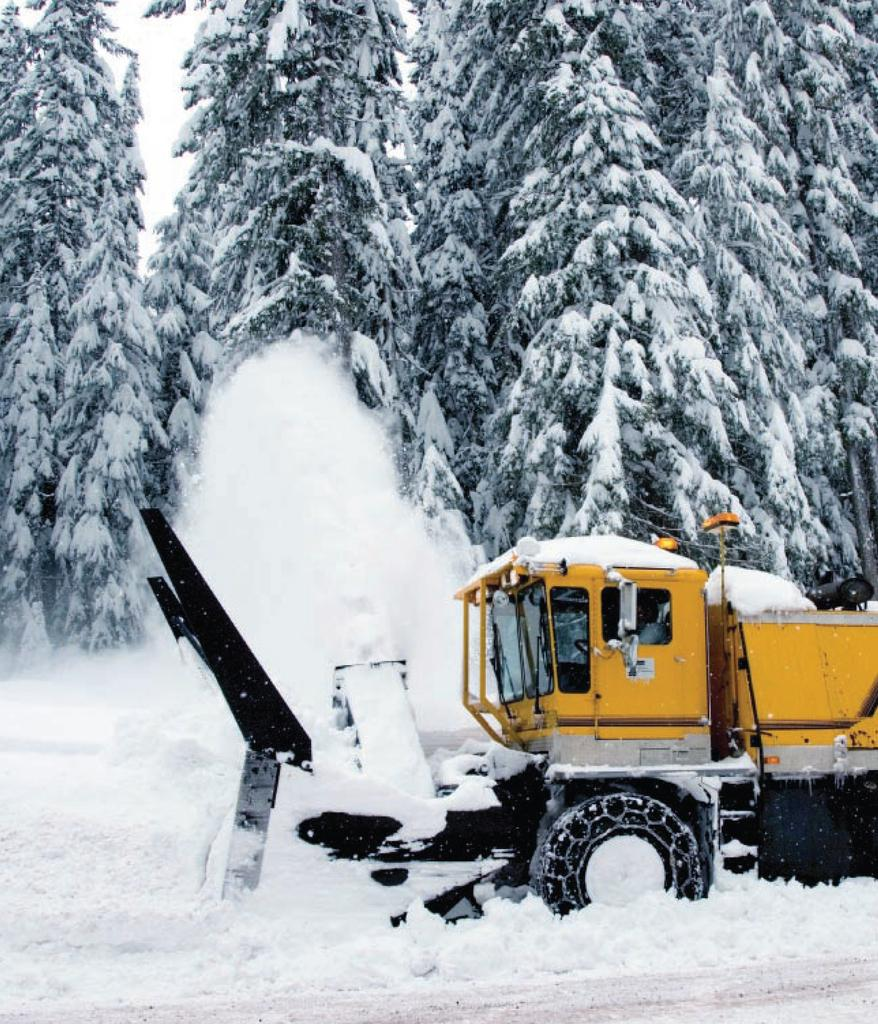What is the main subject of the image? There is a vehicle in the image. Where is the vehicle located? The vehicle is on the snow. What can be seen in the background of the image? There are trees and the sky visible in the background of the image. How long does it take for the pain to subside in the image? There is no mention of pain in the image, as it features a vehicle on the snow with trees and the sky in the background. 